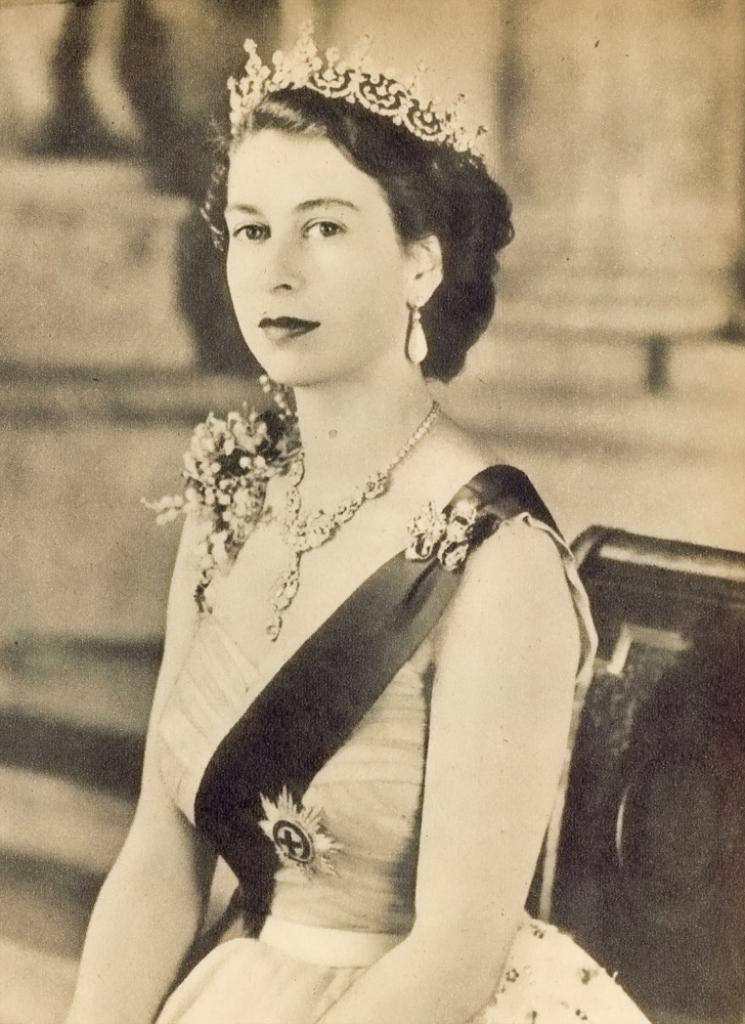Could you give a brief overview of what you see in this image? This is a black and white image. In this image, we can see there is a woman in a dress, smiling. Behind her, there is an object. And the background is blurred. 